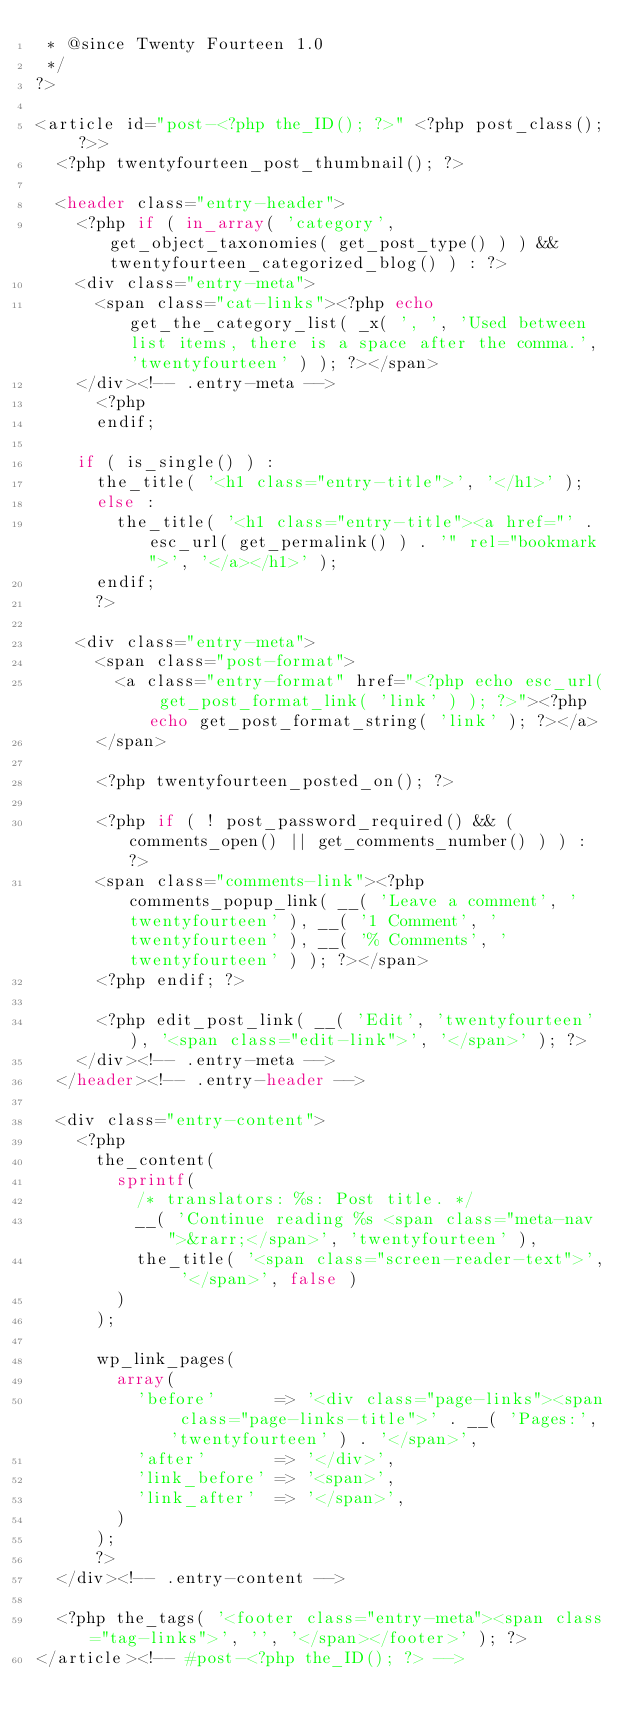Convert code to text. <code><loc_0><loc_0><loc_500><loc_500><_PHP_> * @since Twenty Fourteen 1.0
 */
?>

<article id="post-<?php the_ID(); ?>" <?php post_class(); ?>>
	<?php twentyfourteen_post_thumbnail(); ?>

	<header class="entry-header">
		<?php if ( in_array( 'category', get_object_taxonomies( get_post_type() ) ) && twentyfourteen_categorized_blog() ) : ?>
		<div class="entry-meta">
			<span class="cat-links"><?php echo get_the_category_list( _x( ', ', 'Used between list items, there is a space after the comma.', 'twentyfourteen' ) ); ?></span>
		</div><!-- .entry-meta -->
			<?php
			endif;

		if ( is_single() ) :
			the_title( '<h1 class="entry-title">', '</h1>' );
			else :
				the_title( '<h1 class="entry-title"><a href="' . esc_url( get_permalink() ) . '" rel="bookmark">', '</a></h1>' );
			endif;
			?>

		<div class="entry-meta">
			<span class="post-format">
				<a class="entry-format" href="<?php echo esc_url( get_post_format_link( 'link' ) ); ?>"><?php echo get_post_format_string( 'link' ); ?></a>
			</span>

			<?php twentyfourteen_posted_on(); ?>

			<?php if ( ! post_password_required() && ( comments_open() || get_comments_number() ) ) : ?>
			<span class="comments-link"><?php comments_popup_link( __( 'Leave a comment', 'twentyfourteen' ), __( '1 Comment', 'twentyfourteen' ), __( '% Comments', 'twentyfourteen' ) ); ?></span>
			<?php endif; ?>

			<?php edit_post_link( __( 'Edit', 'twentyfourteen' ), '<span class="edit-link">', '</span>' ); ?>
		</div><!-- .entry-meta -->
	</header><!-- .entry-header -->

	<div class="entry-content">
		<?php
			the_content(
				sprintf(
					/* translators: %s: Post title. */
					__( 'Continue reading %s <span class="meta-nav">&rarr;</span>', 'twentyfourteen' ),
					the_title( '<span class="screen-reader-text">', '</span>', false )
				)
			);

			wp_link_pages(
				array(
					'before'      => '<div class="page-links"><span class="page-links-title">' . __( 'Pages:', 'twentyfourteen' ) . '</span>',
					'after'       => '</div>',
					'link_before' => '<span>',
					'link_after'  => '</span>',
				)
			);
			?>
	</div><!-- .entry-content -->

	<?php the_tags( '<footer class="entry-meta"><span class="tag-links">', '', '</span></footer>' ); ?>
</article><!-- #post-<?php the_ID(); ?> -->
</code> 